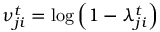Convert formula to latex. <formula><loc_0><loc_0><loc_500><loc_500>\nu _ { j i } ^ { t } = \log \left ( 1 - \lambda _ { j i } ^ { t } \right )</formula> 